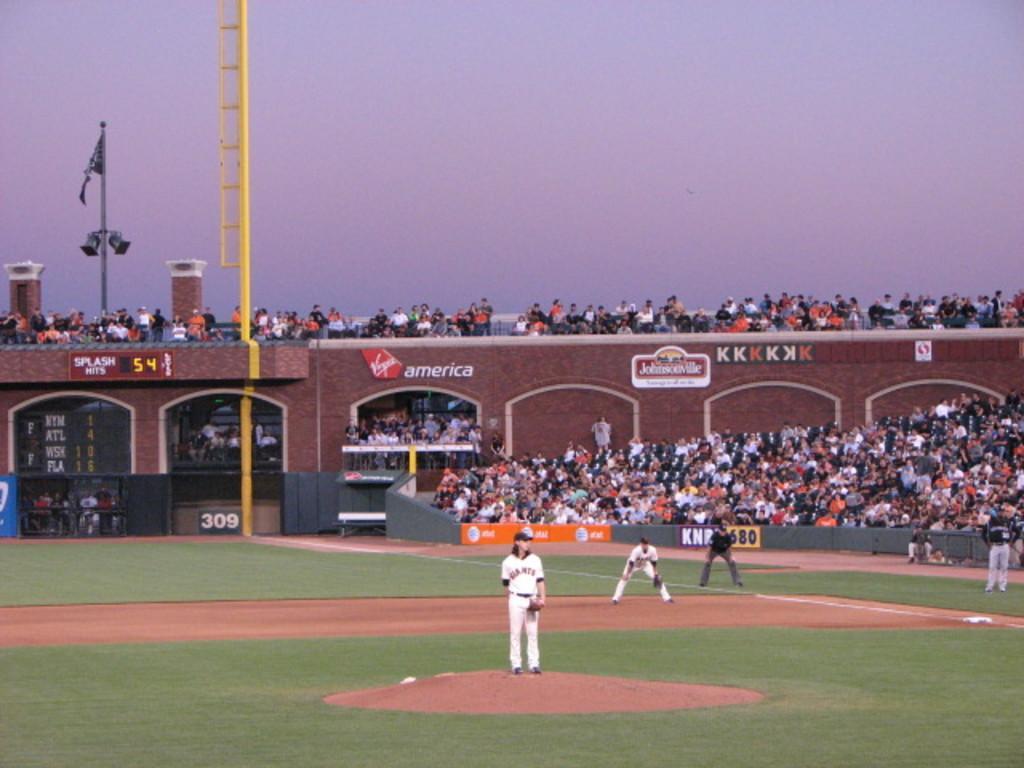Please provide a concise description of this image. In the center of the image we can see a few people are standing on the ground. In the background, we can see the sky, one building, pillars, poles, banners, few people are sitting, few people are standing and a few other objects. 